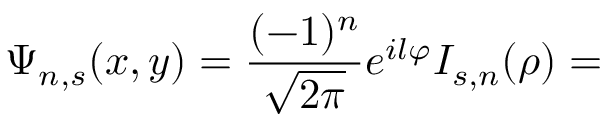Convert formula to latex. <formula><loc_0><loc_0><loc_500><loc_500>\Psi _ { n , s } ( x , y ) = \frac { ( - 1 ) ^ { n } } { \sqrt { 2 \pi } } e ^ { i l \varphi } I _ { s , n } ( \rho ) =</formula> 